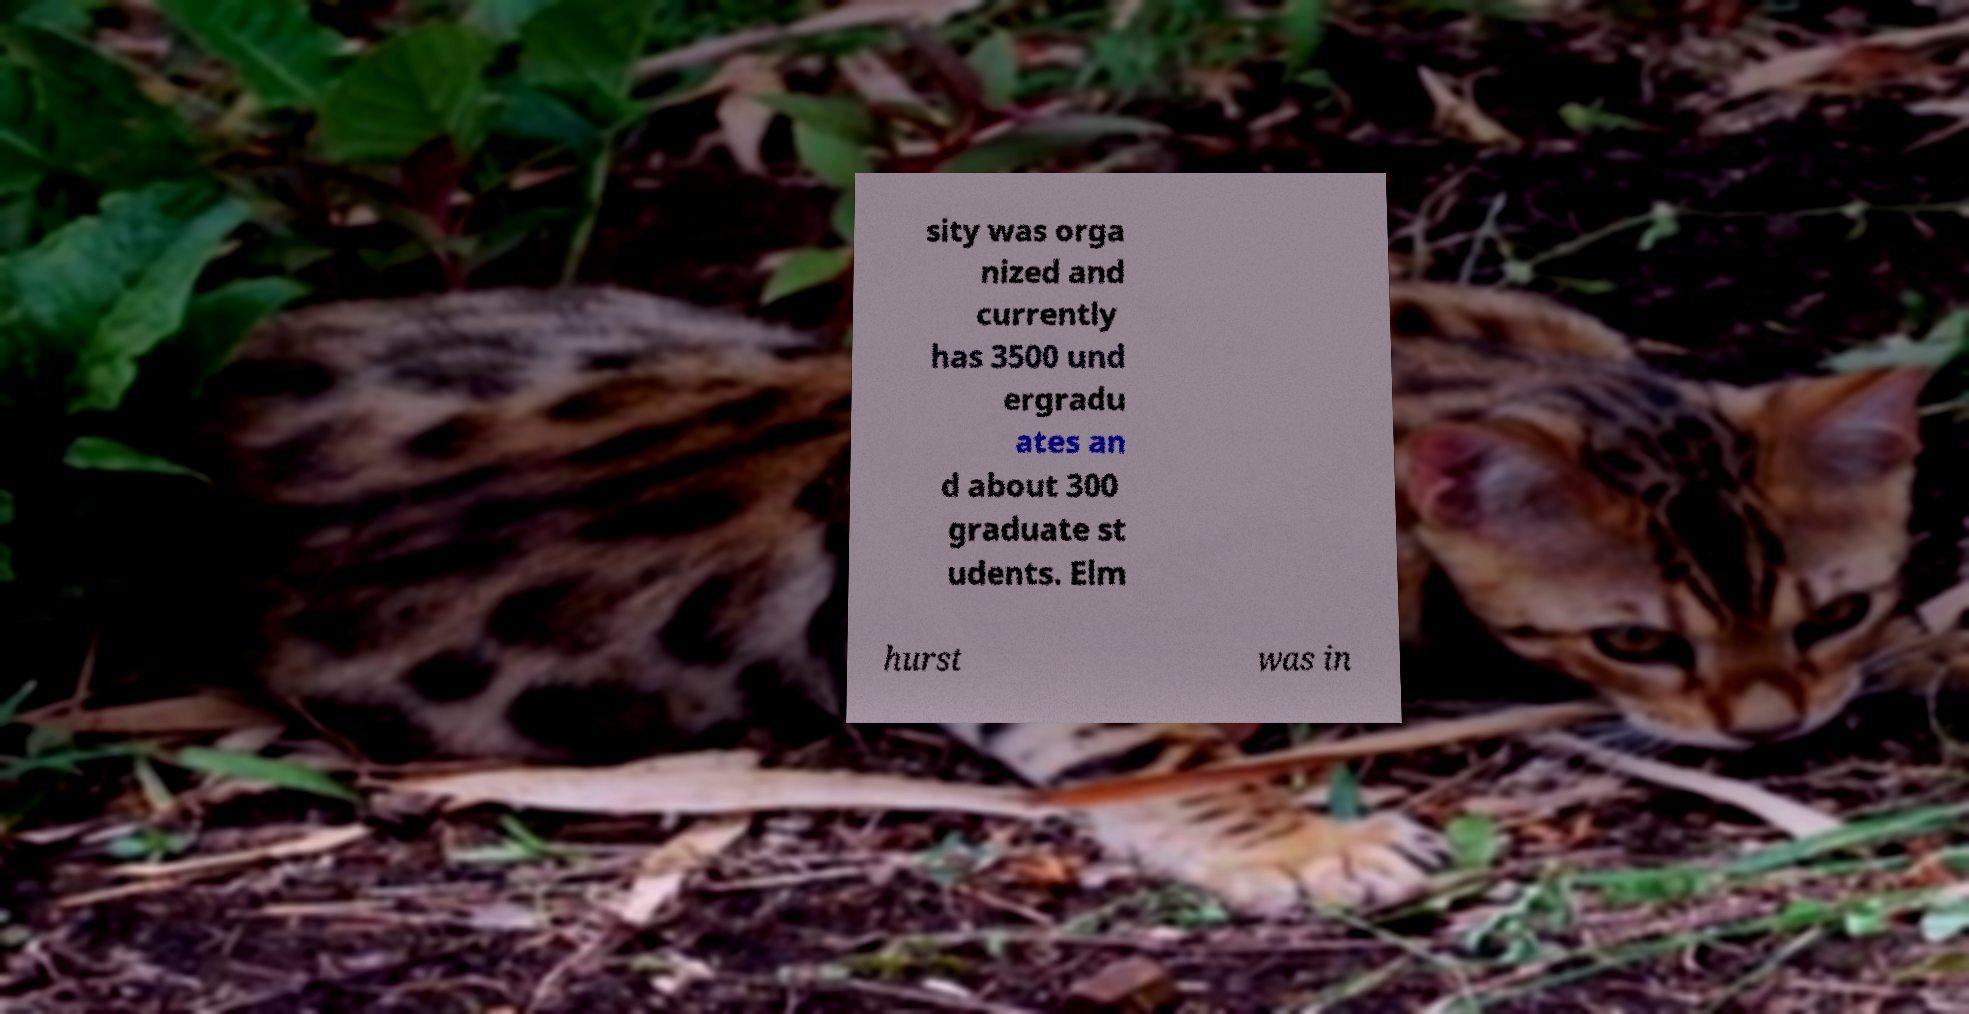Can you read and provide the text displayed in the image?This photo seems to have some interesting text. Can you extract and type it out for me? sity was orga nized and currently has 3500 und ergradu ates an d about 300 graduate st udents. Elm hurst was in 